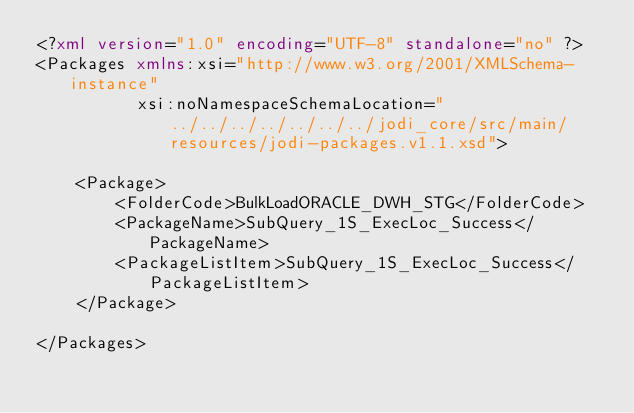<code> <loc_0><loc_0><loc_500><loc_500><_XML_><?xml version="1.0" encoding="UTF-8" standalone="no" ?>
<Packages xmlns:xsi="http://www.w3.org/2001/XMLSchema-instance"
          xsi:noNamespaceSchemaLocation="../../../../../../../jodi_core/src/main/resources/jodi-packages.v1.1.xsd">

    <Package>
        <FolderCode>BulkLoadORACLE_DWH_STG</FolderCode>
        <PackageName>SubQuery_1S_ExecLoc_Success</PackageName>
        <PackageListItem>SubQuery_1S_ExecLoc_Success</PackageListItem>
    </Package>

</Packages></code> 